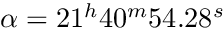Convert formula to latex. <formula><loc_0><loc_0><loc_500><loc_500>\alpha = 2 1 ^ { h } 4 0 ^ { m } 5 4 . 2 8 ^ { s }</formula> 